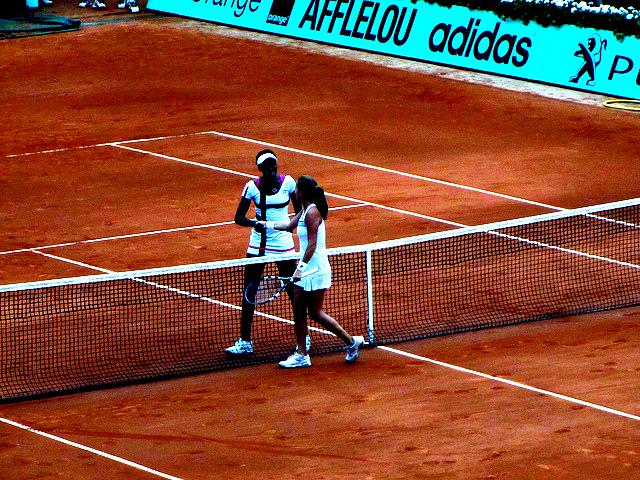Can you describe the emotions of the players based on their body language? Although the exact emotions are not clear from this distance, the body language of the players, with one seemingly comforting or encouraging the other, suggests camaraderie and support. They might be discussing tactics, congratulating each other on a good play, or one might be consoling the other after a challenging point. 